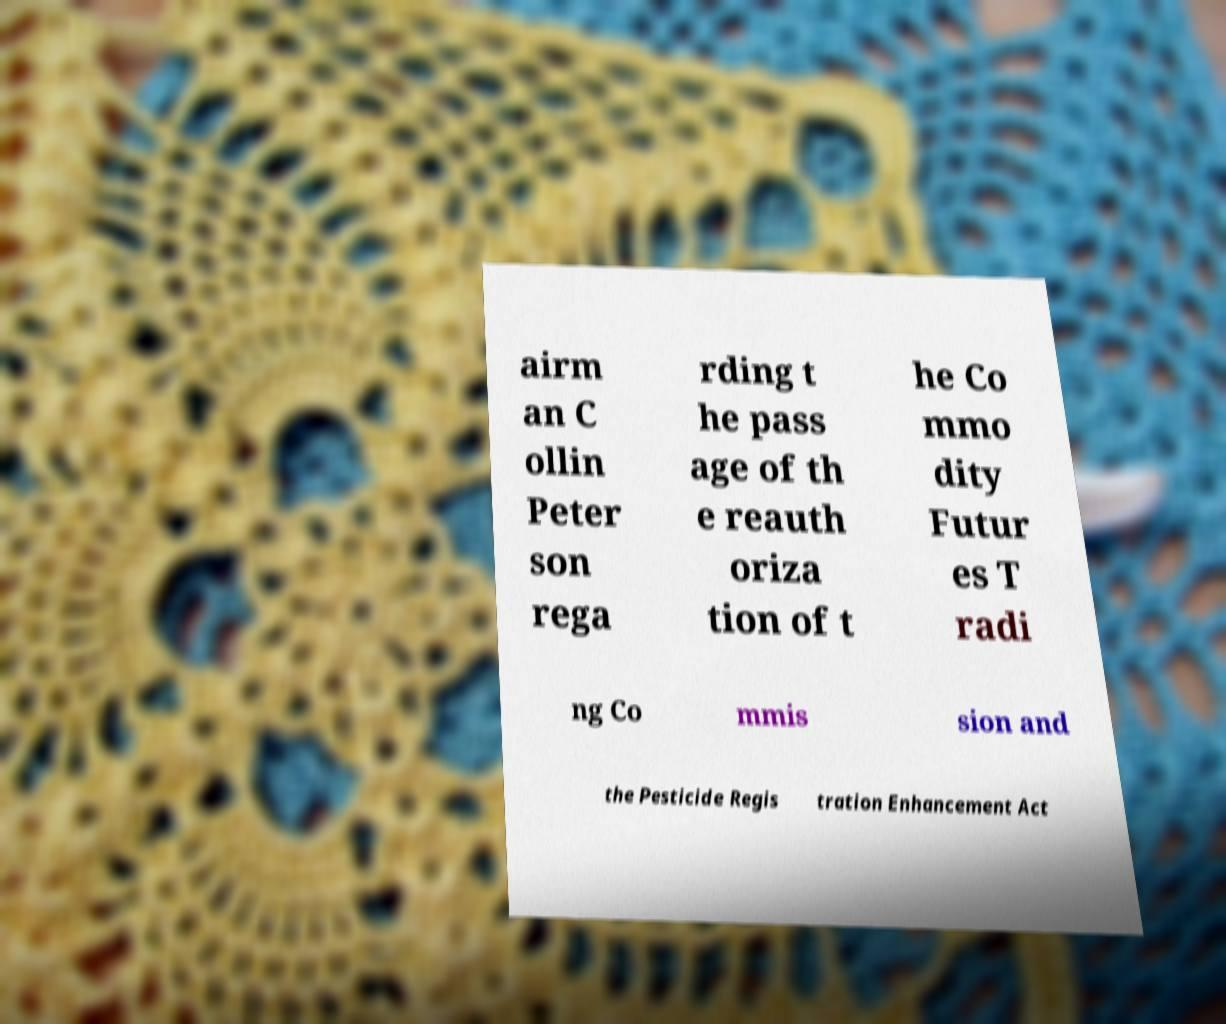Could you assist in decoding the text presented in this image and type it out clearly? airm an C ollin Peter son rega rding t he pass age of th e reauth oriza tion of t he Co mmo dity Futur es T radi ng Co mmis sion and the Pesticide Regis tration Enhancement Act 